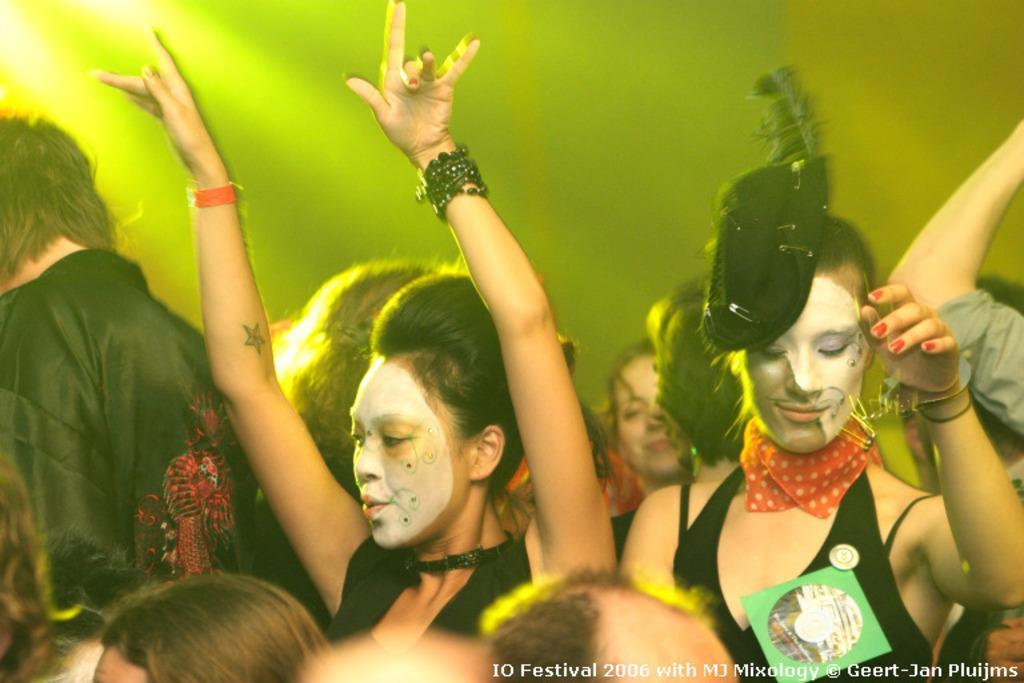Could you give a brief overview of what you see in this image? In this image we can see many people. A lady is wearing a hat. There is a light focus in the image. There is some text at the bottom left side of the image. 